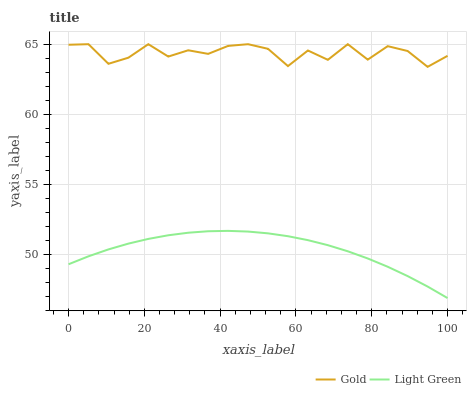Does Light Green have the minimum area under the curve?
Answer yes or no. Yes. Does Gold have the maximum area under the curve?
Answer yes or no. Yes. Does Gold have the minimum area under the curve?
Answer yes or no. No. Is Light Green the smoothest?
Answer yes or no. Yes. Is Gold the roughest?
Answer yes or no. Yes. Is Gold the smoothest?
Answer yes or no. No. Does Light Green have the lowest value?
Answer yes or no. Yes. Does Gold have the lowest value?
Answer yes or no. No. Does Gold have the highest value?
Answer yes or no. Yes. Is Light Green less than Gold?
Answer yes or no. Yes. Is Gold greater than Light Green?
Answer yes or no. Yes. Does Light Green intersect Gold?
Answer yes or no. No. 